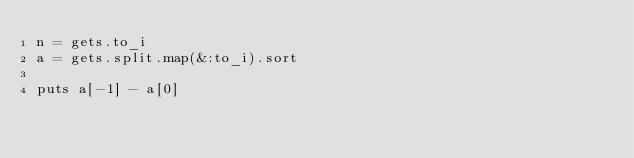Convert code to text. <code><loc_0><loc_0><loc_500><loc_500><_Ruby_>n = gets.to_i
a = gets.split.map(&:to_i).sort

puts a[-1] - a[0]</code> 